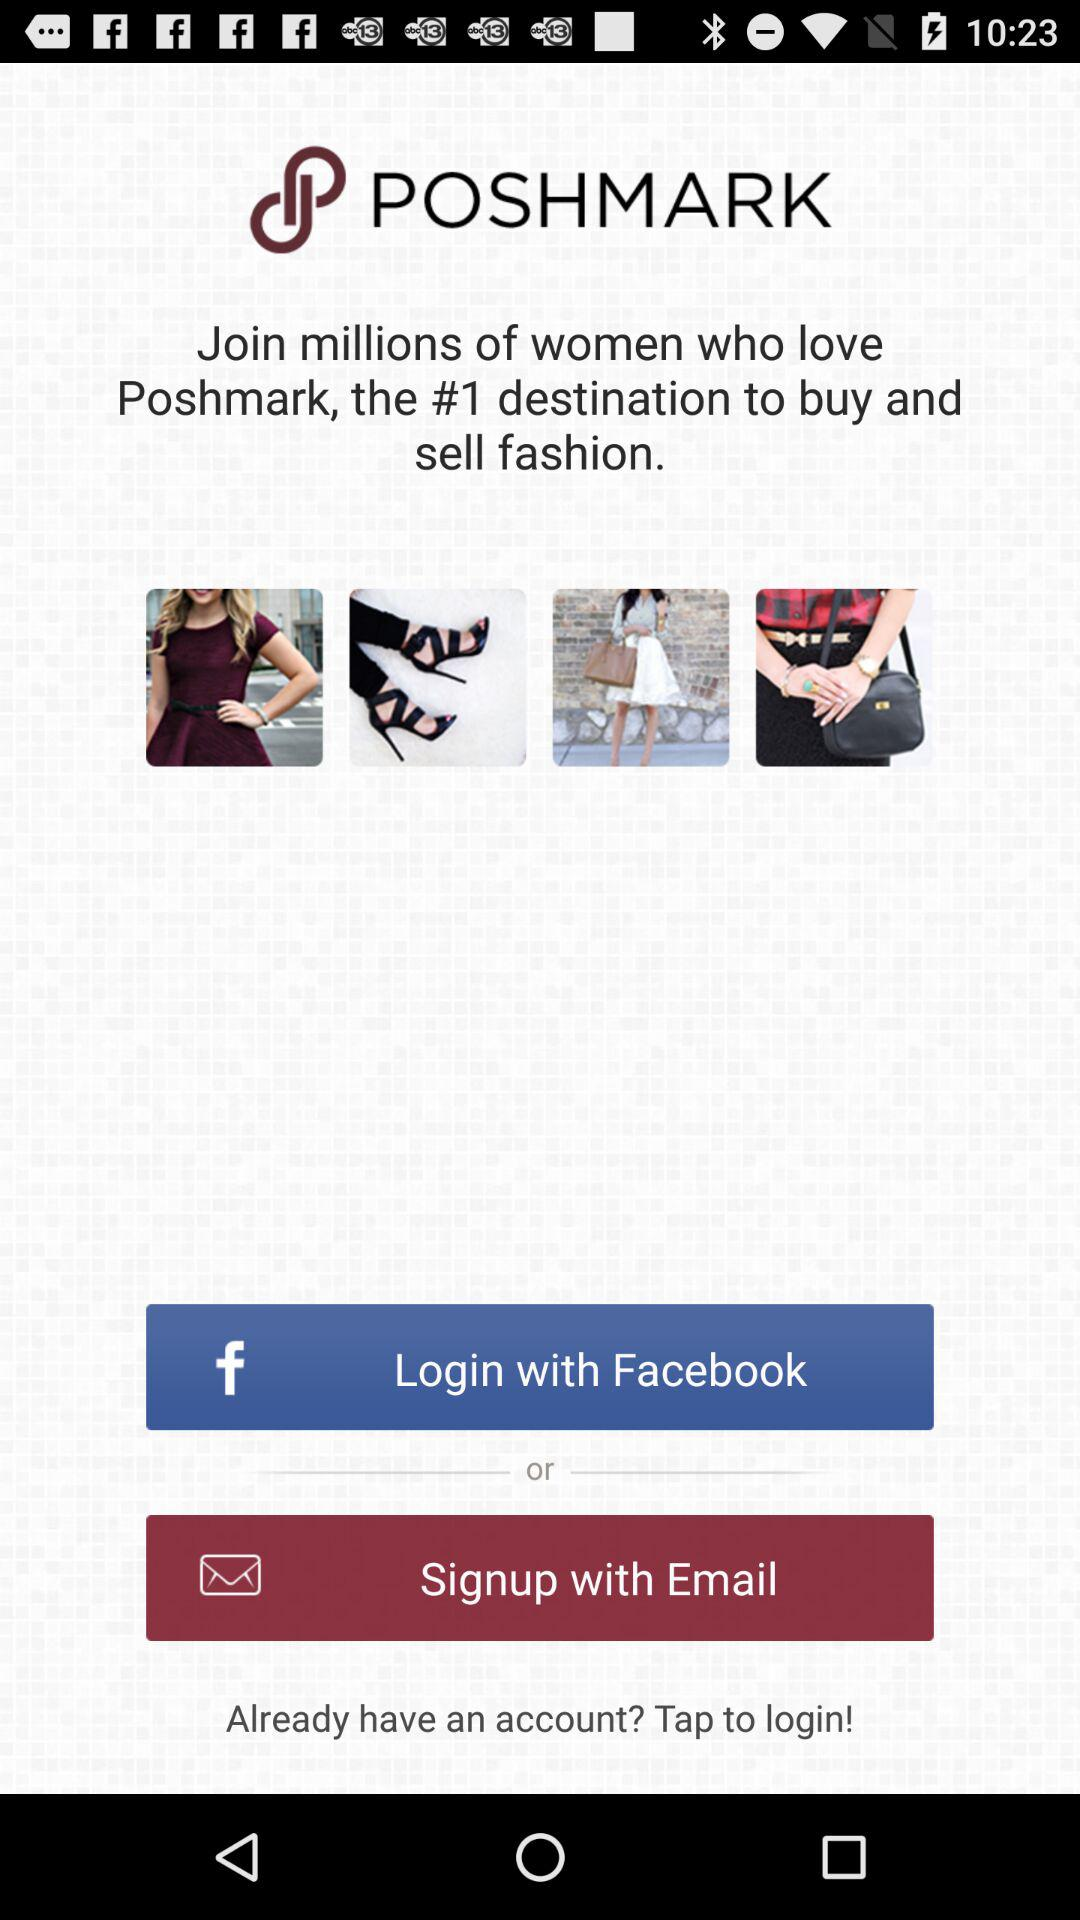What applications can we use to log in? You can log in with "Facebook". 